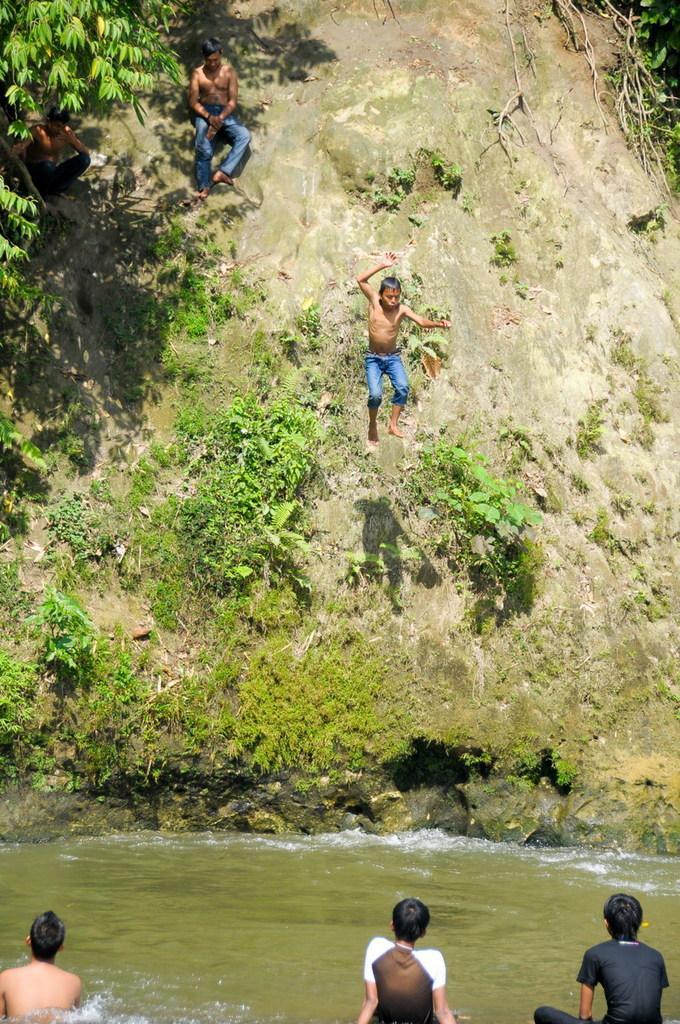Please provide a concise description of this image. In the center of the image, we can see a person jumping and at the bottom, there are people and there is water. In the background, there are trees and we can see a hill and some people sitting on the hill. 